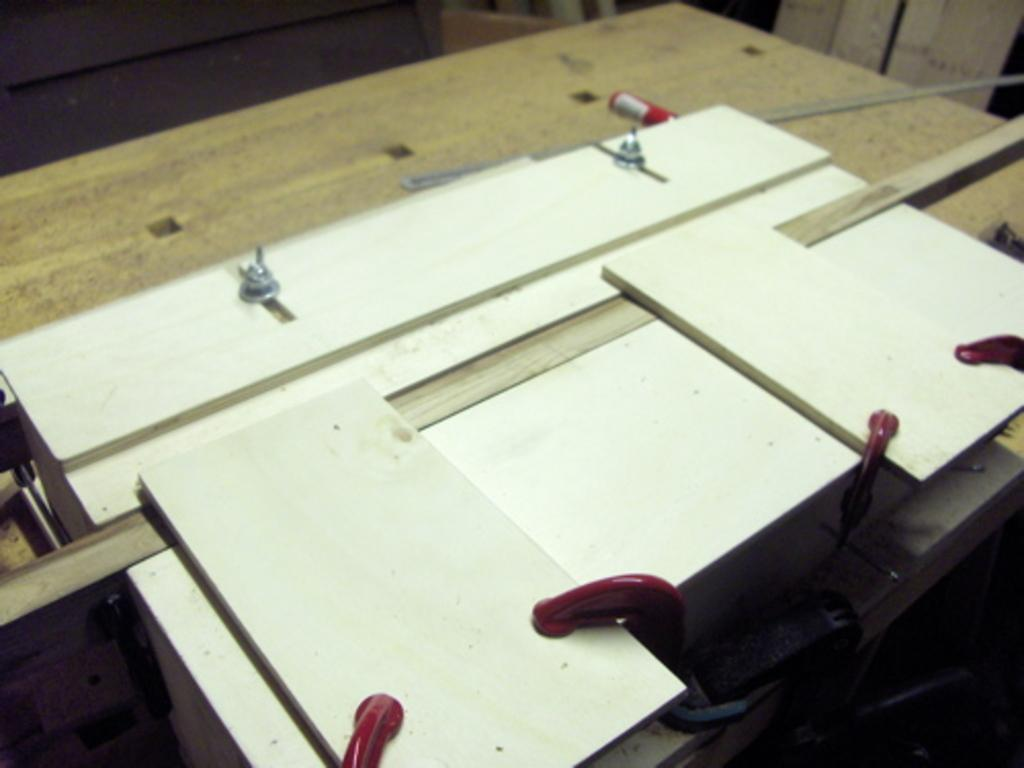What type of objects can be seen in the image? There are cardboards in the image. What tool is visible in the image? There is a marker in the image. What device is present in the image? There is a scale in the image. On what surface are the objects placed? The objects are on a wooden table. How does the celery contribute to the pollution in the image? There is no celery present in the image, so it cannot contribute to any pollution. 